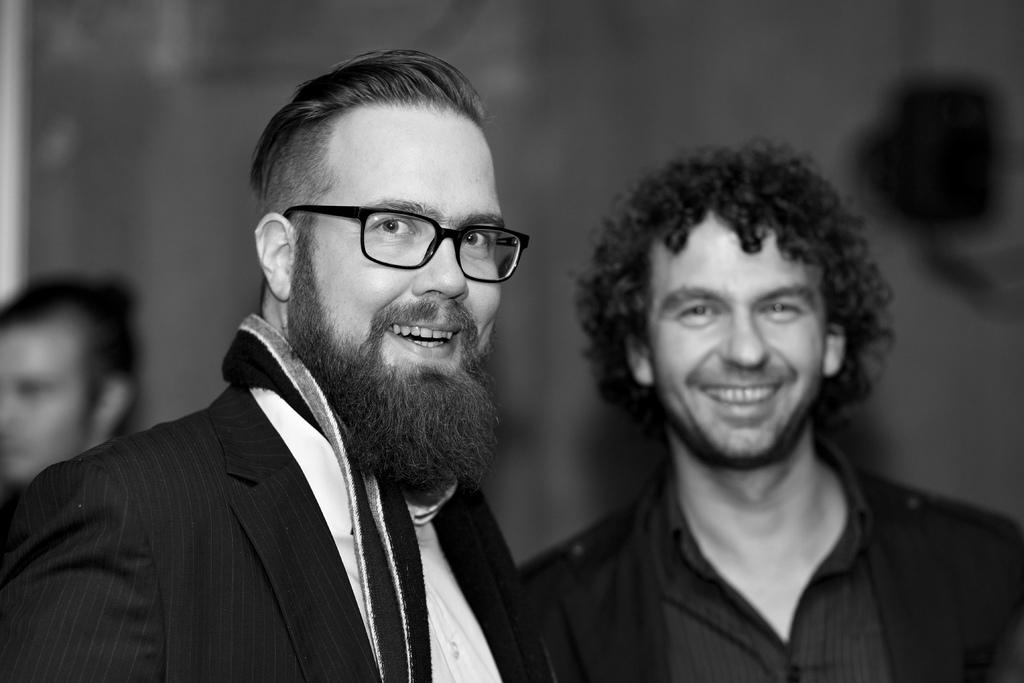How many people are visible in the image? There are two persons standing and smiling in the image. Is there anyone else in the image besides the two smiling persons? Yes, there is a third person standing in the background of the image. Can you describe the background of the image? The background of the image is blurred. What type of need is being traded between the geese in the image? There are no geese present in the image, so it is not possible to determine what, if any, need might be traded between them. 